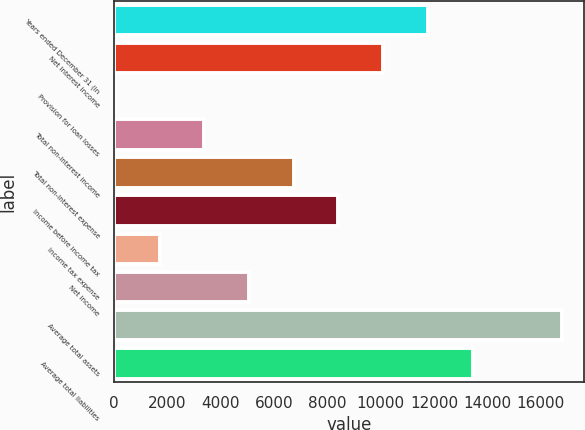<chart> <loc_0><loc_0><loc_500><loc_500><bar_chart><fcel>Years ended December 31 (in<fcel>Net interest income<fcel>Provision for loan losses<fcel>Total non-interest income<fcel>Total non-interest expense<fcel>Income before income tax<fcel>Income tax expense<fcel>Net income<fcel>Average total assets<fcel>Average total liabilities<nl><fcel>11767.8<fcel>10093.4<fcel>46.9<fcel>3395.72<fcel>6744.54<fcel>8418.95<fcel>1721.31<fcel>5070.13<fcel>16791<fcel>13442.2<nl></chart> 